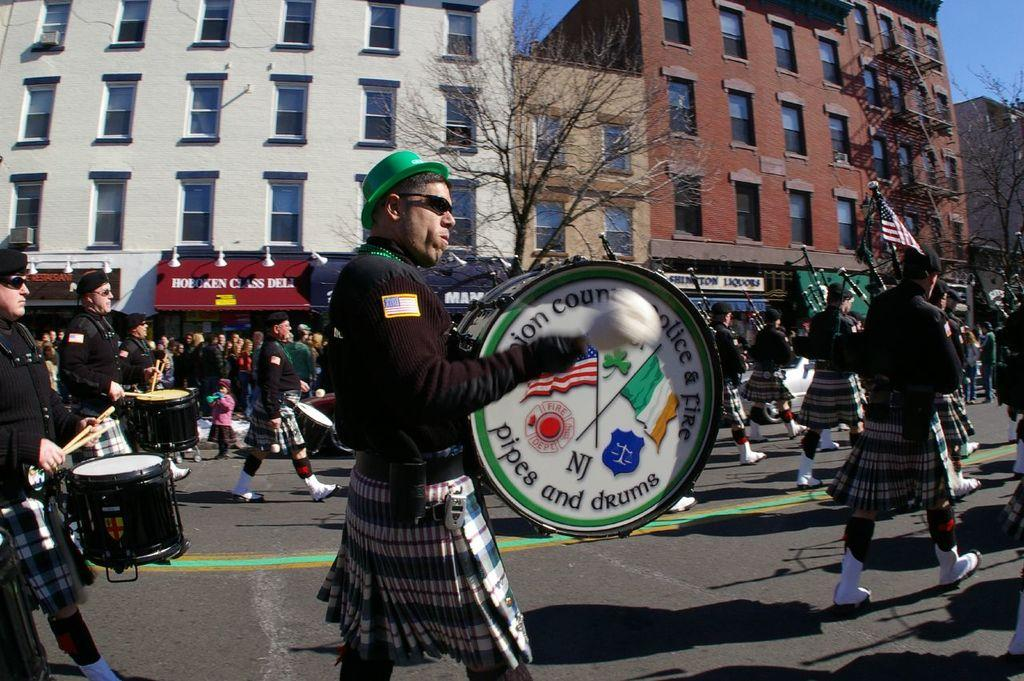How many people are in the group in the image? There is a group of people in the image, but the exact number is not specified. What are some of the people in the group doing? Some people in the group are walking, and some are playing a drum set. What can be seen in the background of the image? There is a tree and a building visible in the background of the image. How many bikes are parked near the building in the image? There is no mention of bikes in the image, so we cannot determine how many are parked near the building. What is the back of the building like in the image? The provided facts do not mention the back of the building, so we cannot describe it. 